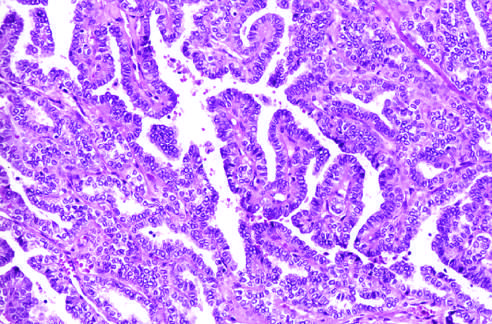what are lined by cells with characteristic empty-appearing nuclei, sometimes termed orphan annie eye nuclei c in this particular example?
Answer the question using a single word or phrase. Well-formed papillae 